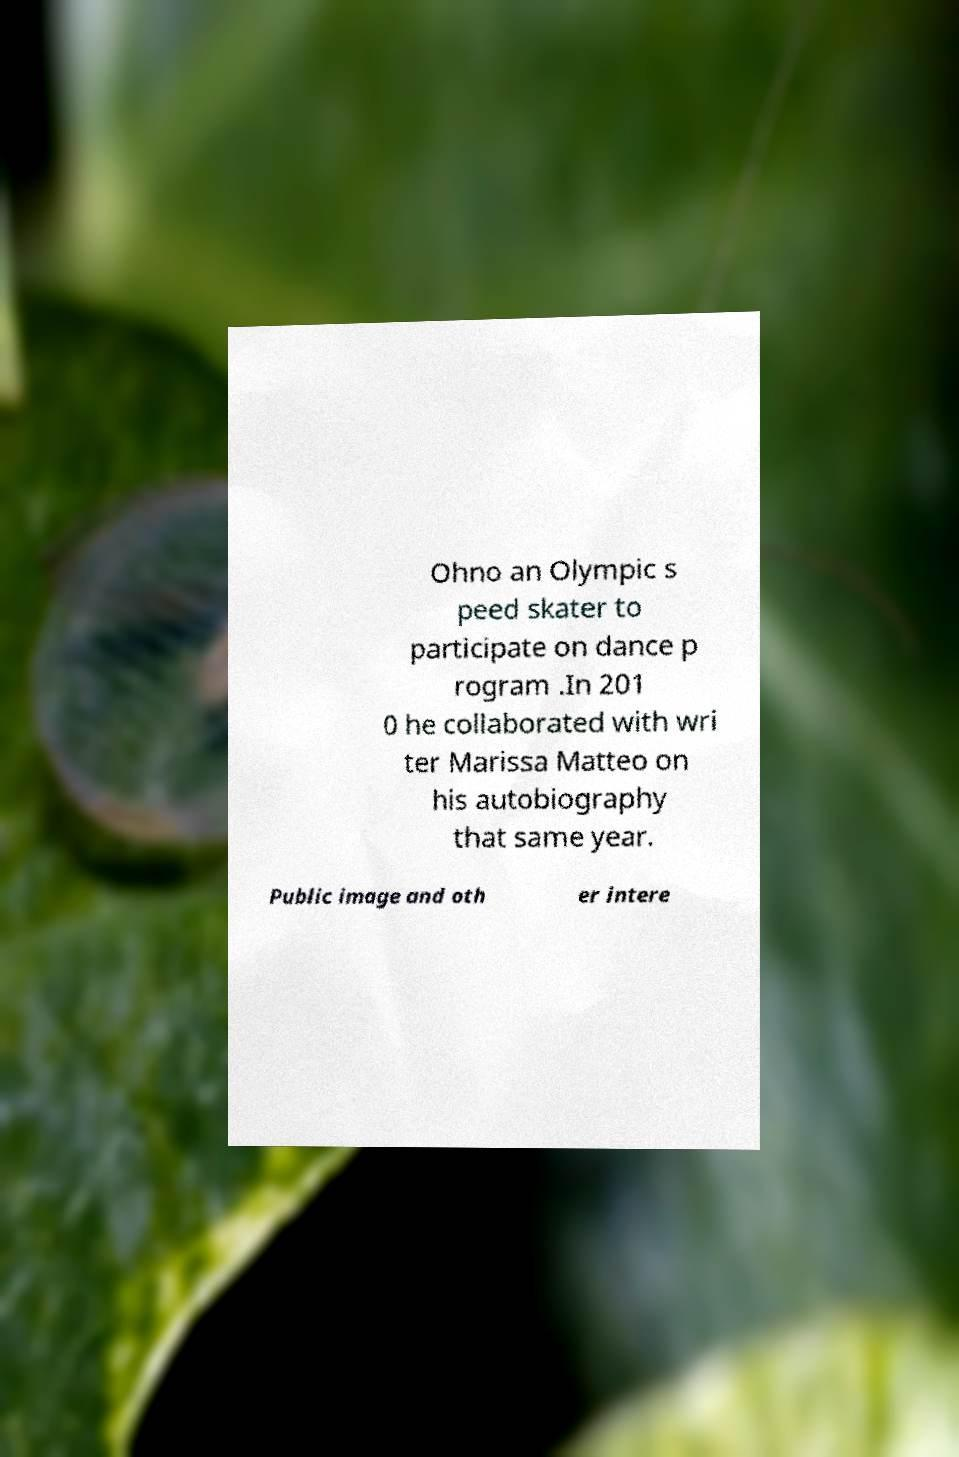Could you assist in decoding the text presented in this image and type it out clearly? Ohno an Olympic s peed skater to participate on dance p rogram .In 201 0 he collaborated with wri ter Marissa Matteo on his autobiography that same year. Public image and oth er intere 